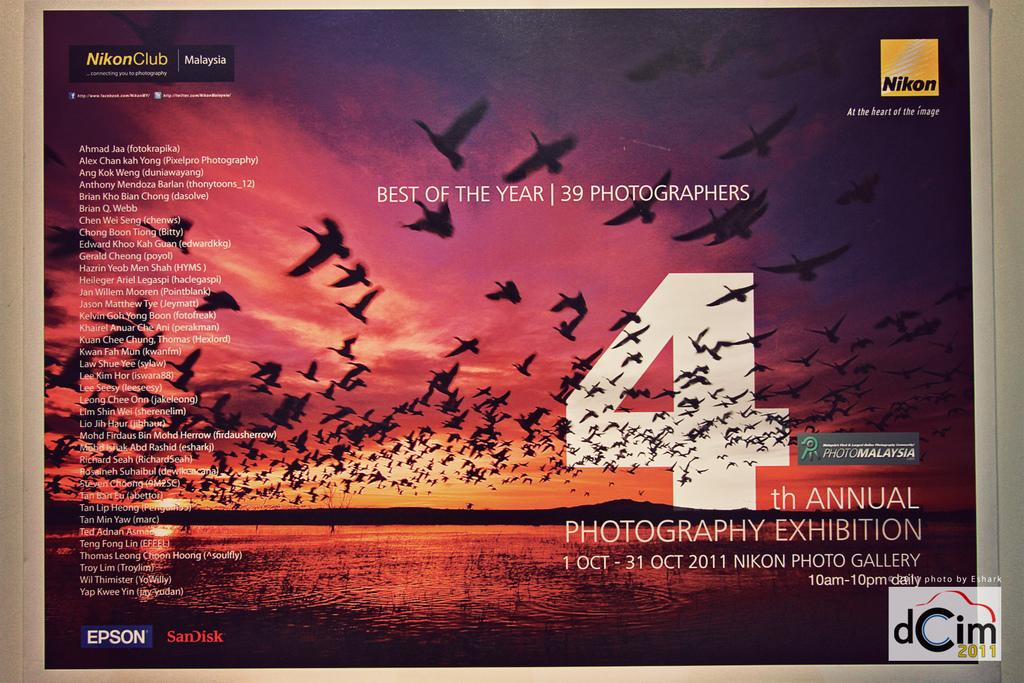Provide a one-sentence caption for the provided image. A poster advertising the best photos of the year saying it is the fourth annual. 